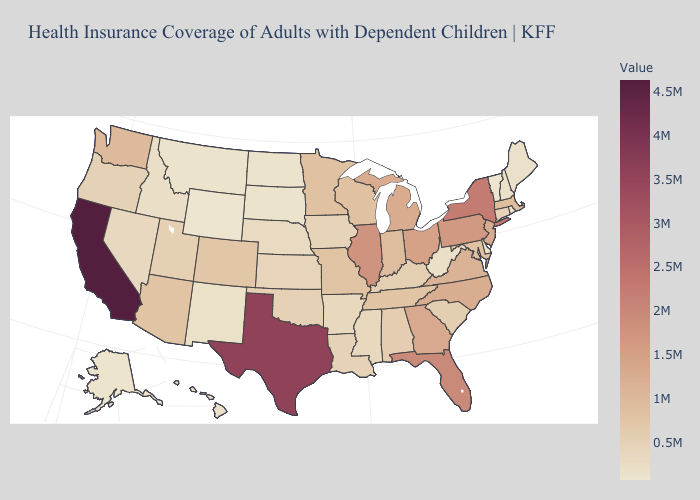Which states have the lowest value in the USA?
Be succinct. Vermont. Does California have the highest value in the USA?
Keep it brief. Yes. Among the states that border Michigan , which have the highest value?
Keep it brief. Ohio. Does Kentucky have the highest value in the South?
Short answer required. No. Among the states that border Idaho , which have the highest value?
Concise answer only. Washington. 